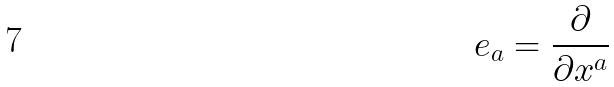<formula> <loc_0><loc_0><loc_500><loc_500>e _ { a } = \frac { \partial } { \partial x ^ { a } }</formula> 